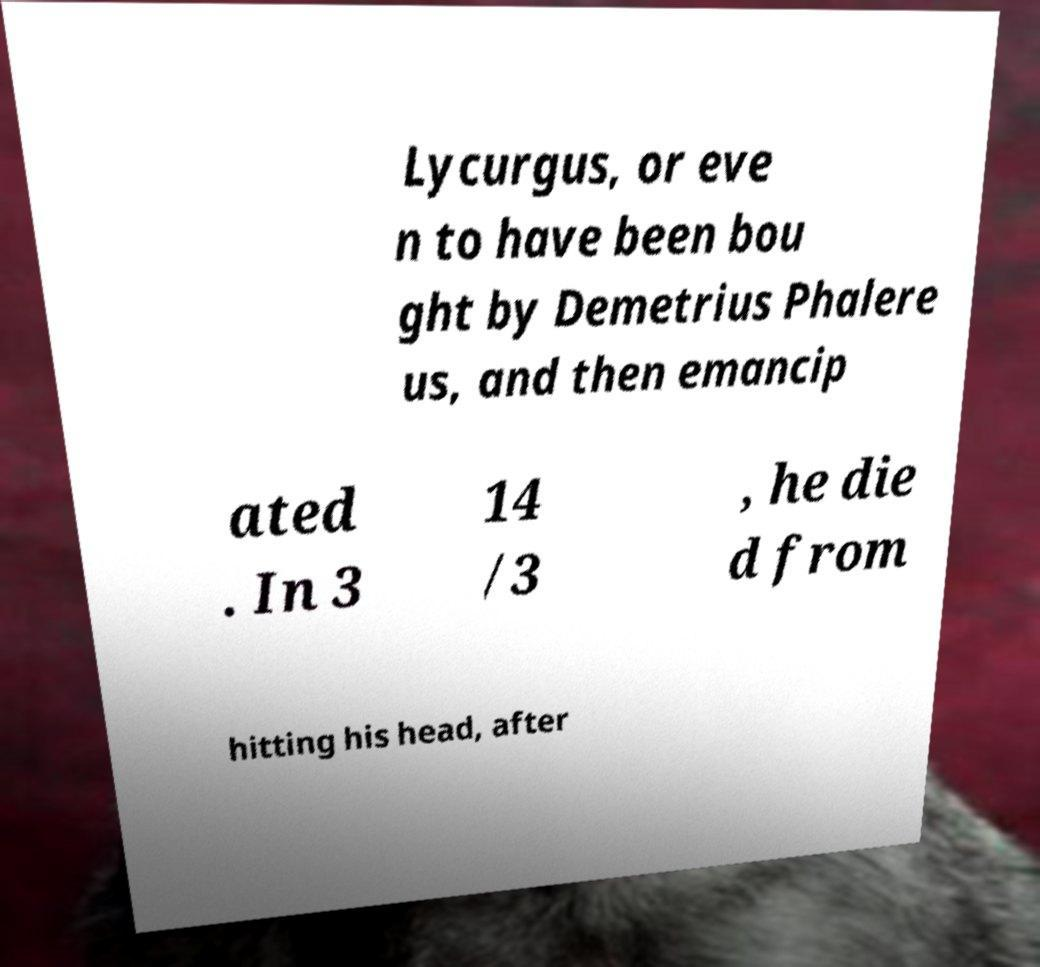What messages or text are displayed in this image? I need them in a readable, typed format. Lycurgus, or eve n to have been bou ght by Demetrius Phalere us, and then emancip ated . In 3 14 /3 , he die d from hitting his head, after 